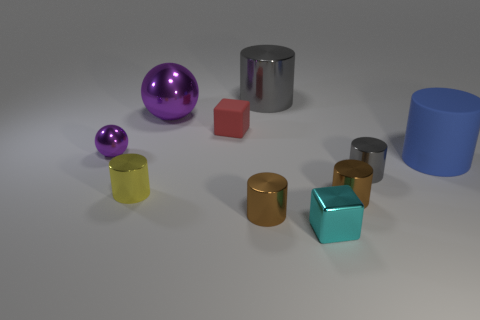Does the gray shiny thing that is behind the red matte cube have the same shape as the large blue object?
Your answer should be very brief. Yes. How many things are either large blue matte spheres or big spheres?
Offer a terse response. 1. Do the cube that is behind the small purple thing and the cyan cube have the same material?
Offer a very short reply. No. What size is the red matte block?
Your answer should be compact. Small. There is a shiny thing that is the same color as the big metallic cylinder; what is its shape?
Offer a very short reply. Cylinder. What number of cubes are tiny cyan metallic things or blue objects?
Keep it short and to the point. 1. Is the number of rubber cylinders on the left side of the blue object the same as the number of purple shiny balls that are to the right of the red rubber thing?
Offer a very short reply. Yes. There is a cyan shiny object that is the same shape as the red matte object; what size is it?
Offer a very short reply. Small. There is a metal object that is both in front of the big shiny cylinder and behind the tiny purple shiny object; what size is it?
Make the answer very short. Large. Are there any cyan shiny objects right of the big purple shiny object?
Your answer should be compact. Yes. 